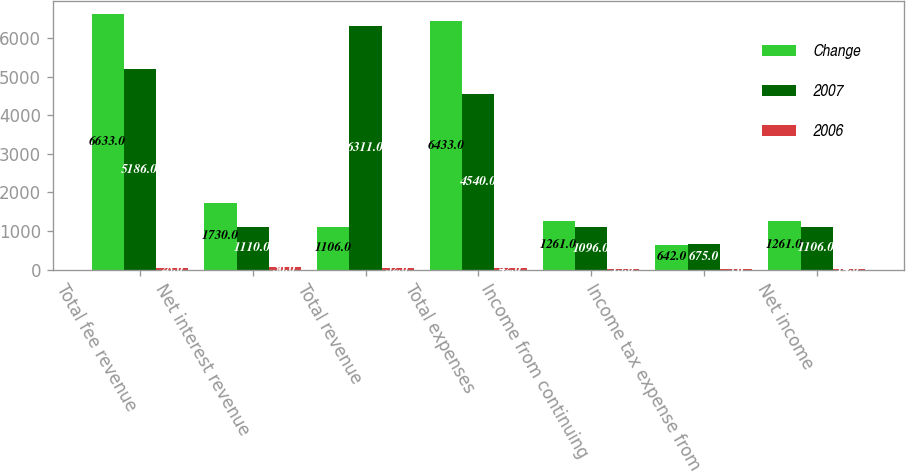Convert chart. <chart><loc_0><loc_0><loc_500><loc_500><stacked_bar_chart><ecel><fcel>Total fee revenue<fcel>Net interest revenue<fcel>Total revenue<fcel>Total expenses<fcel>Income from continuing<fcel>Income tax expense from<fcel>Net income<nl><fcel>Change<fcel>6633<fcel>1730<fcel>1106<fcel>6433<fcel>1261<fcel>642<fcel>1261<nl><fcel>2007<fcel>5186<fcel>1110<fcel>6311<fcel>4540<fcel>1096<fcel>675<fcel>1106<nl><fcel>2006<fcel>28<fcel>56<fcel>32<fcel>42<fcel>15<fcel>5<fcel>14<nl></chart> 